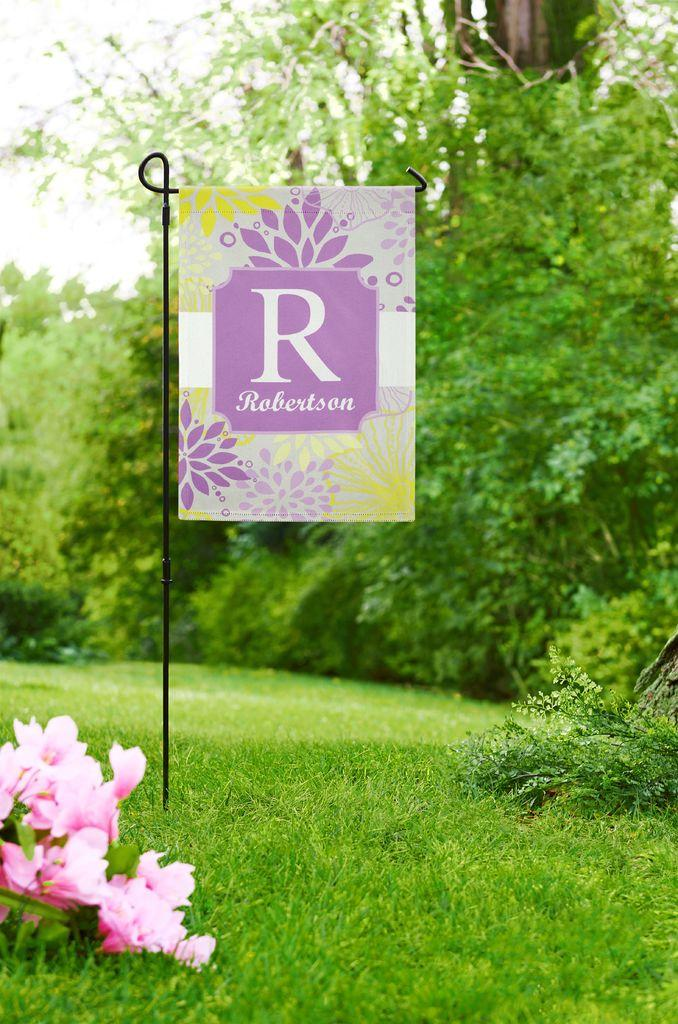What is hanging from the rod in the image? There is a banner in the image that is attached to a rod. What color are the flowers in the image? There are pink flowers in the image. What can be seen in the background of the image? There are trees in the background of the image. What is the color of the trees in the image? The trees are green. What is visible above the trees in the image? The sky is visible in the image. What is the color of the sky in the image? The sky is white in the image. Can you see any snails crawling on the banner in the image? There are no snails visible on the banner in the image. What type of food does the turkey in the image prefer to bite? There is no turkey present in the image, so it is not possible to determine its food preferences. 